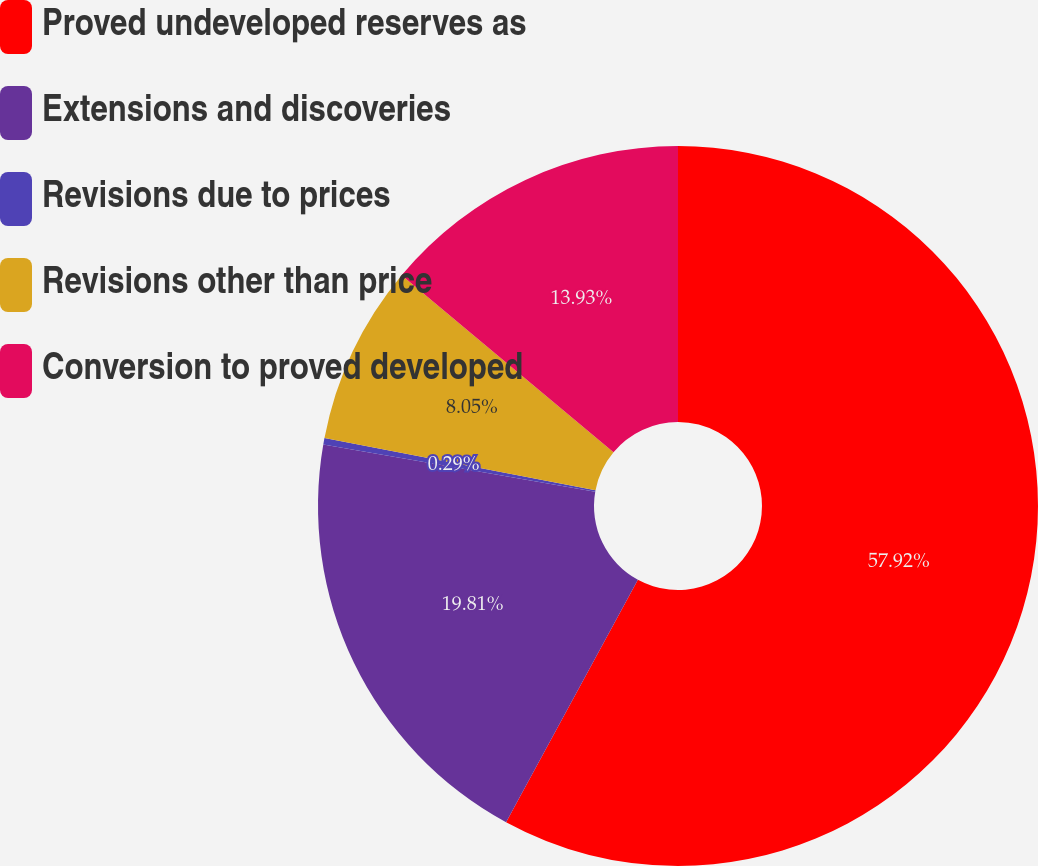<chart> <loc_0><loc_0><loc_500><loc_500><pie_chart><fcel>Proved undeveloped reserves as<fcel>Extensions and discoveries<fcel>Revisions due to prices<fcel>Revisions other than price<fcel>Conversion to proved developed<nl><fcel>57.93%<fcel>19.81%<fcel>0.29%<fcel>8.05%<fcel>13.93%<nl></chart> 